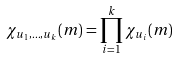<formula> <loc_0><loc_0><loc_500><loc_500>\chi _ { u _ { 1 } , \dots , u _ { k } } ( m ) = \prod _ { i = 1 } ^ { k } \chi _ { u _ { i } } ( m )</formula> 